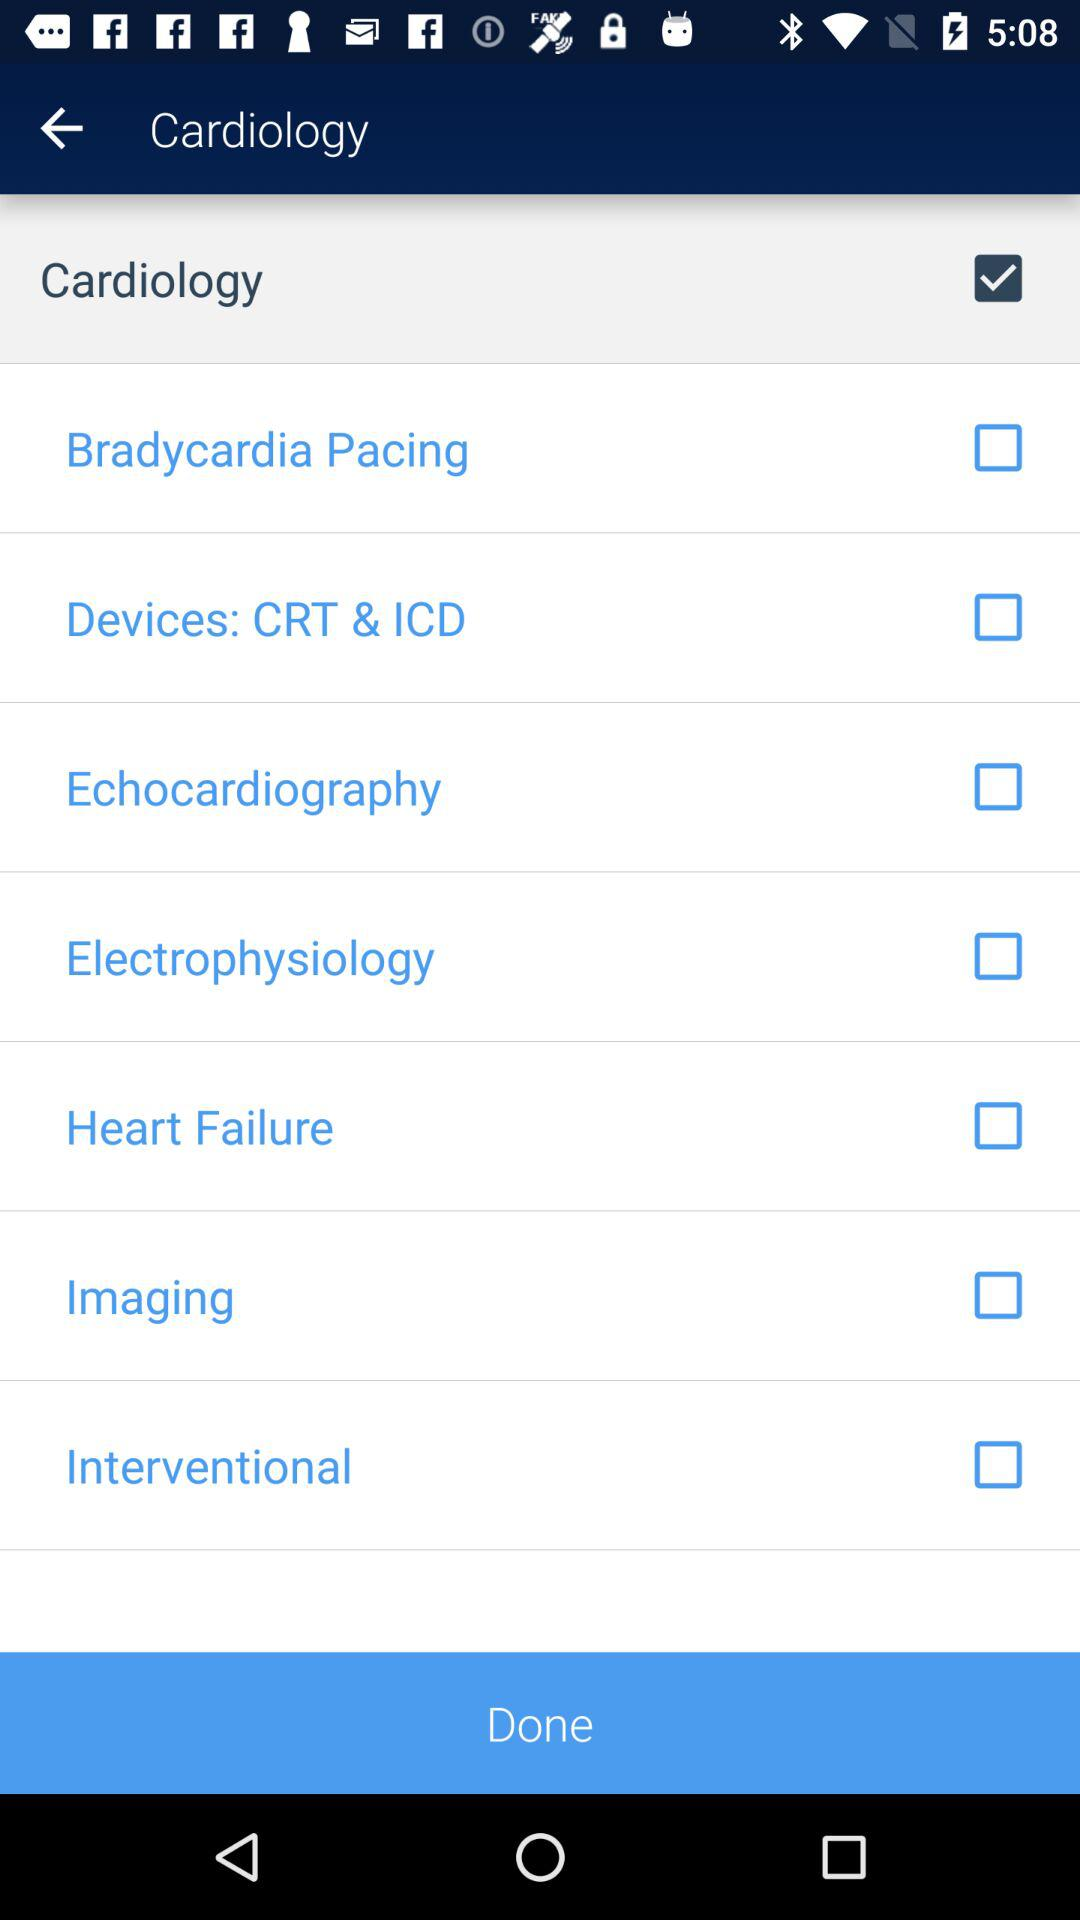Which checkbox is selected? The selected checkbox is "Cardiology". 